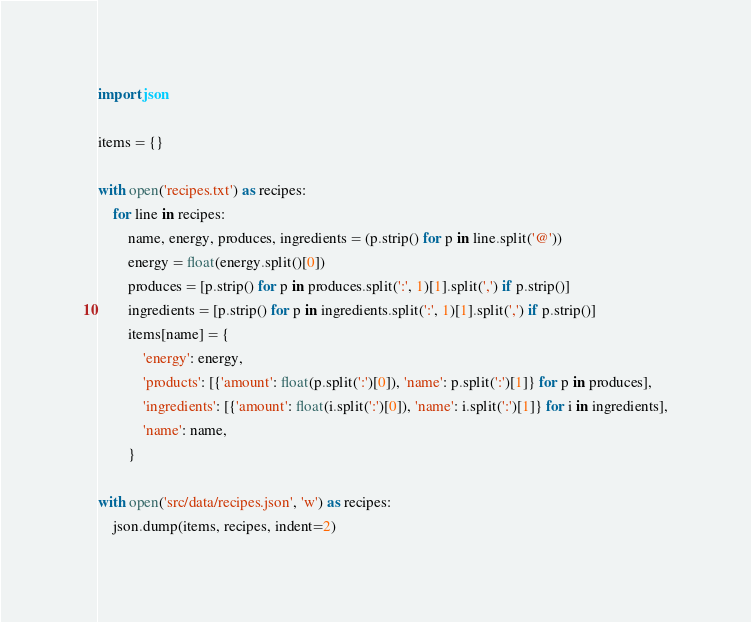Convert code to text. <code><loc_0><loc_0><loc_500><loc_500><_Python_>import json

items = {}

with open('recipes.txt') as recipes:
    for line in recipes:
        name, energy, produces, ingredients = (p.strip() for p in line.split('@'))
        energy = float(energy.split()[0])
        produces = [p.strip() for p in produces.split(':', 1)[1].split(',') if p.strip()]
        ingredients = [p.strip() for p in ingredients.split(':', 1)[1].split(',') if p.strip()]
        items[name] = {
            'energy': energy,
            'products': [{'amount': float(p.split(':')[0]), 'name': p.split(':')[1]} for p in produces],
            'ingredients': [{'amount': float(i.split(':')[0]), 'name': i.split(':')[1]} for i in ingredients],
            'name': name,
        }

with open('src/data/recipes.json', 'w') as recipes:
    json.dump(items, recipes, indent=2)
</code> 